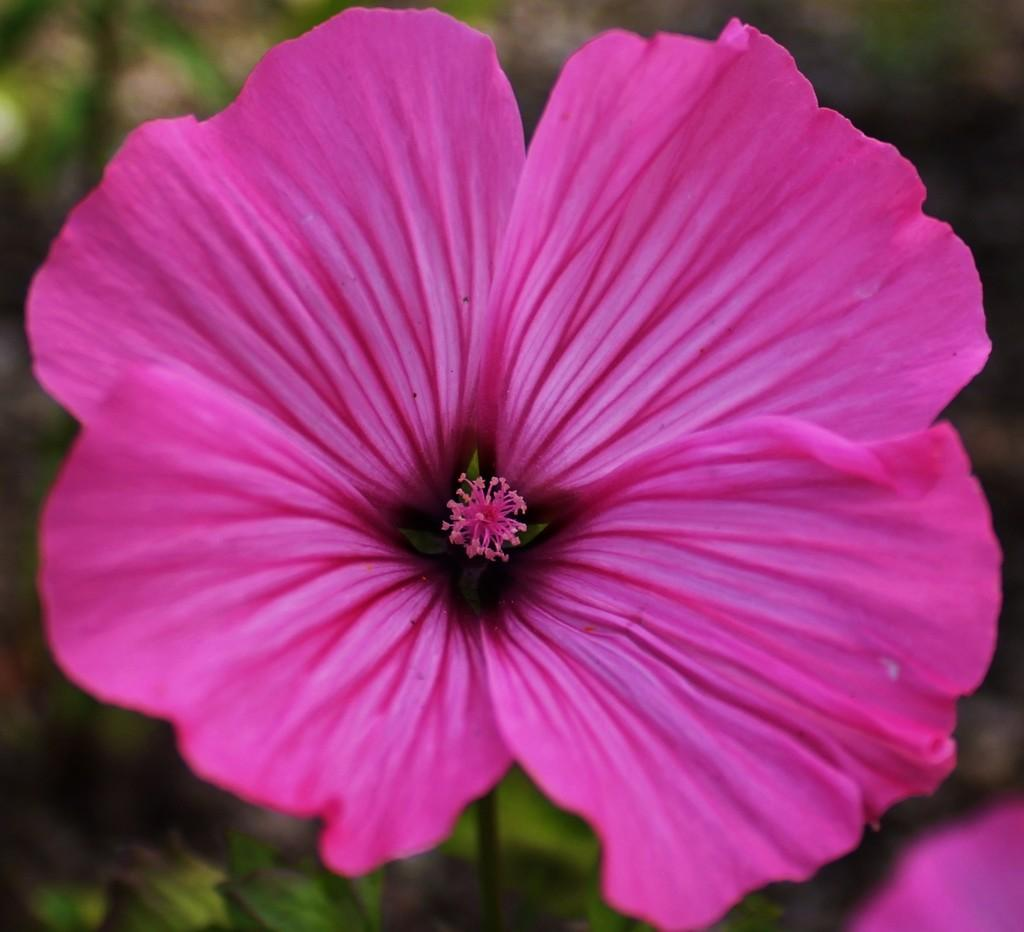What color are the flowers in the image? The flowers in the image are pink-colored. How many sheep are grazing in the field with the pink flowers? There are no sheep present in the image; it only features pink-colored flowers. 